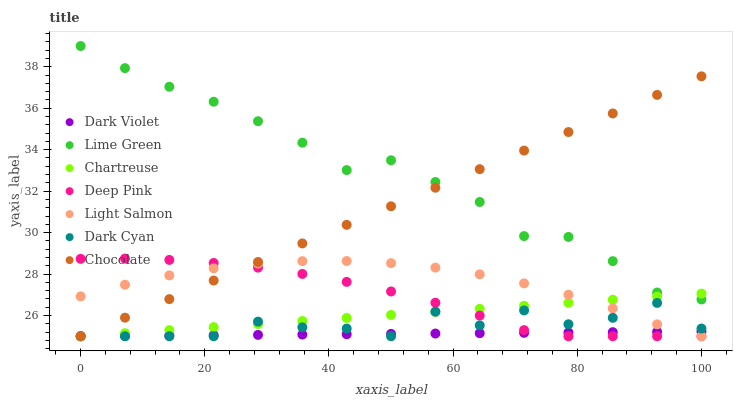Does Dark Violet have the minimum area under the curve?
Answer yes or no. Yes. Does Lime Green have the maximum area under the curve?
Answer yes or no. Yes. Does Deep Pink have the minimum area under the curve?
Answer yes or no. No. Does Deep Pink have the maximum area under the curve?
Answer yes or no. No. Is Chartreuse the smoothest?
Answer yes or no. Yes. Is Dark Cyan the roughest?
Answer yes or no. Yes. Is Deep Pink the smoothest?
Answer yes or no. No. Is Deep Pink the roughest?
Answer yes or no. No. Does Light Salmon have the lowest value?
Answer yes or no. Yes. Does Lime Green have the lowest value?
Answer yes or no. No. Does Lime Green have the highest value?
Answer yes or no. Yes. Does Deep Pink have the highest value?
Answer yes or no. No. Is Dark Violet less than Lime Green?
Answer yes or no. Yes. Is Lime Green greater than Dark Cyan?
Answer yes or no. Yes. Does Chartreuse intersect Dark Violet?
Answer yes or no. Yes. Is Chartreuse less than Dark Violet?
Answer yes or no. No. Is Chartreuse greater than Dark Violet?
Answer yes or no. No. Does Dark Violet intersect Lime Green?
Answer yes or no. No. 